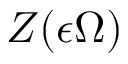Convert formula to latex. <formula><loc_0><loc_0><loc_500><loc_500>Z ( \epsilon \Omega )</formula> 